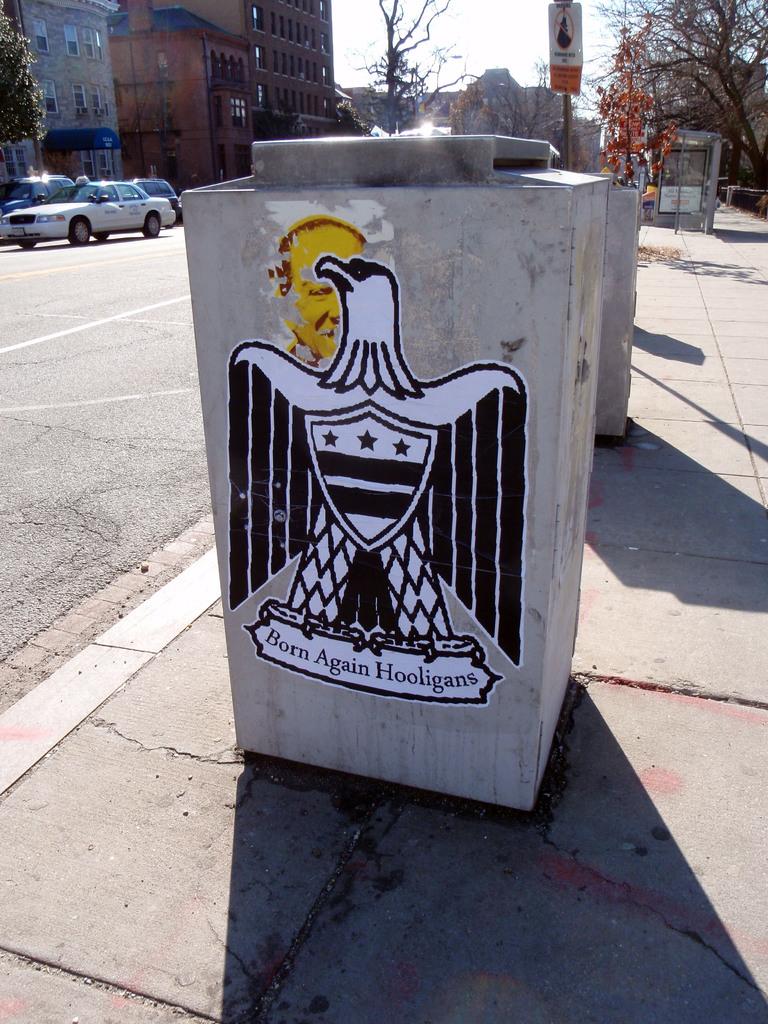What group made this crest?
Provide a short and direct response. Born again hooligans. 